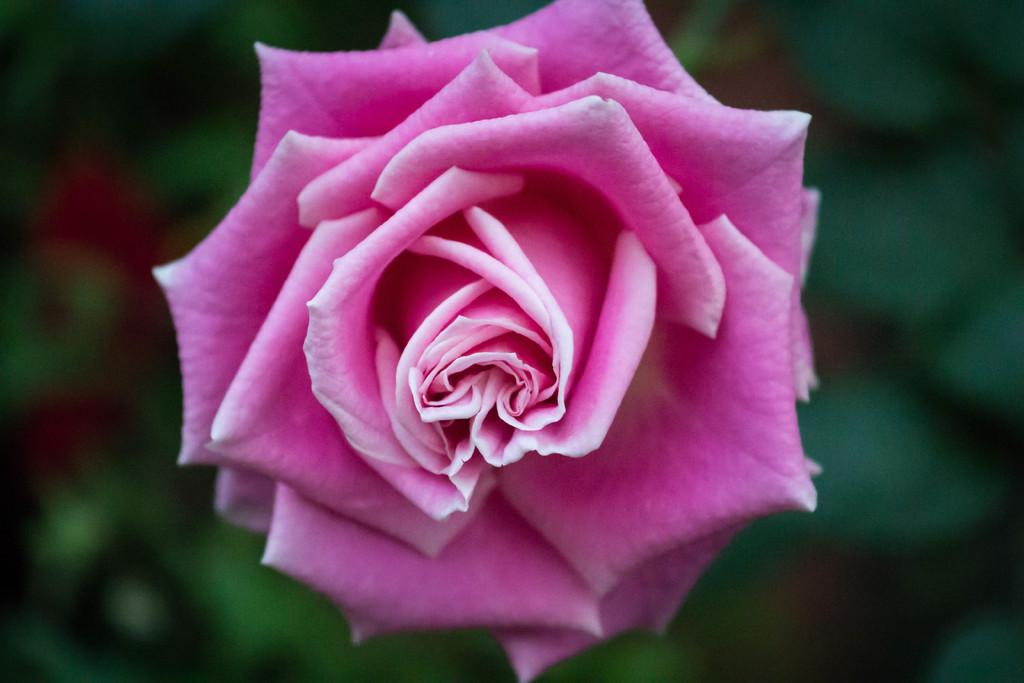What type of flower is in the image? There is a pink color rose in the image. What can be seen in the background of the image? The background is green and blurred. How many chairs are placed around the board in the image? There is no board or chairs present in the image; it features a pink color rose with a green blurred background. 